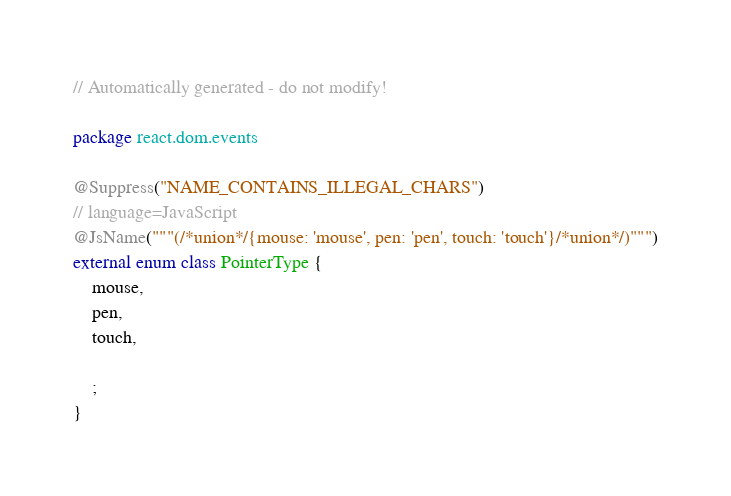Convert code to text. <code><loc_0><loc_0><loc_500><loc_500><_Kotlin_>// Automatically generated - do not modify!

package react.dom.events

@Suppress("NAME_CONTAINS_ILLEGAL_CHARS")
// language=JavaScript
@JsName("""(/*union*/{mouse: 'mouse', pen: 'pen', touch: 'touch'}/*union*/)""")
external enum class PointerType {
    mouse,
    pen,
    touch,

    ;
}
</code> 